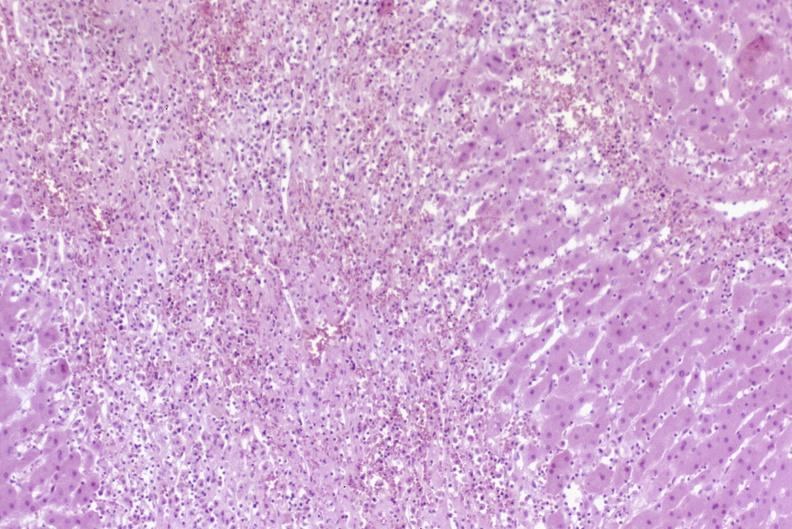what is present?
Answer the question using a single word or phrase. Liver 